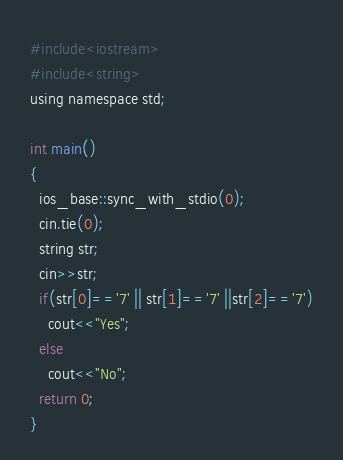<code> <loc_0><loc_0><loc_500><loc_500><_C_>#include<iostream>
#include<string>
using namespace std;

int main()
{
  ios_base::sync_with_stdio(0);
  cin.tie(0);
  string str;
  cin>>str;
  if(str[0]=='7' || str[1]=='7' ||str[2]=='7')
    cout<<"Yes";
  else
    cout<<"No";
  return 0;
}</code> 